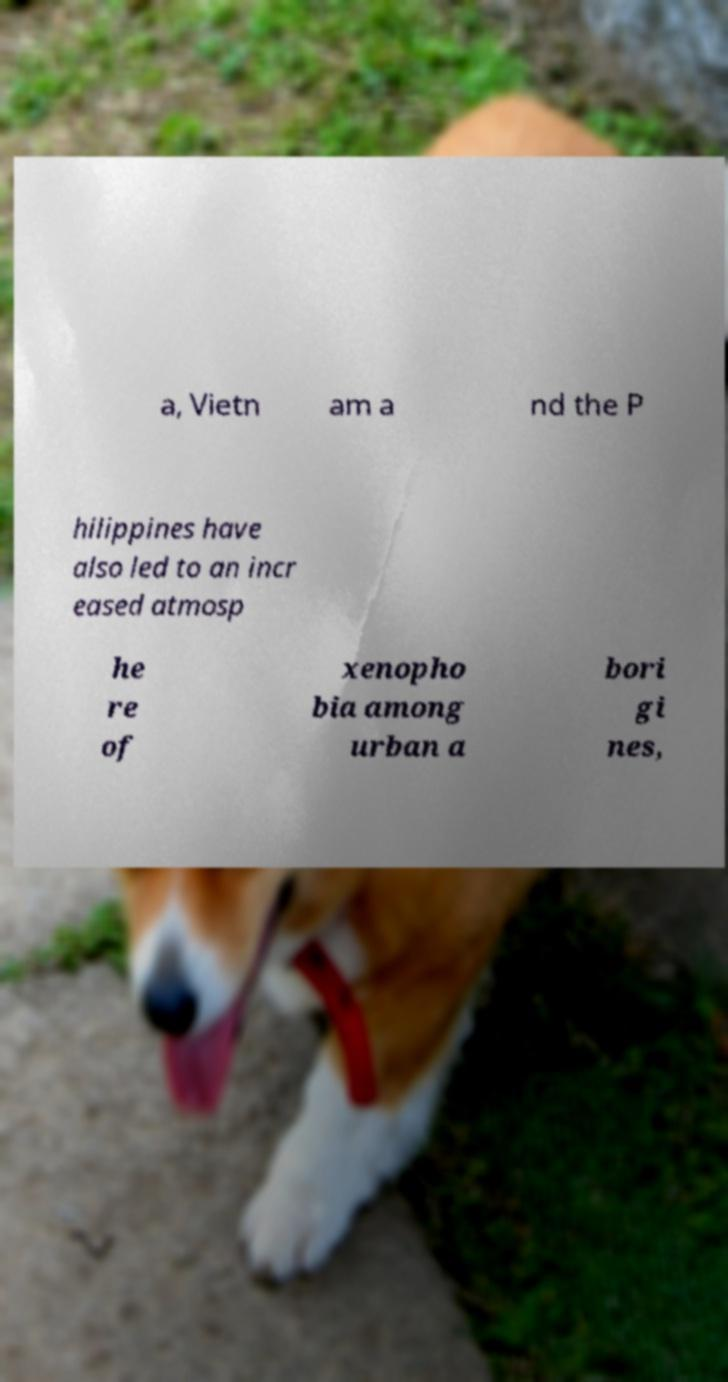For documentation purposes, I need the text within this image transcribed. Could you provide that? a, Vietn am a nd the P hilippines have also led to an incr eased atmosp he re of xenopho bia among urban a bori gi nes, 